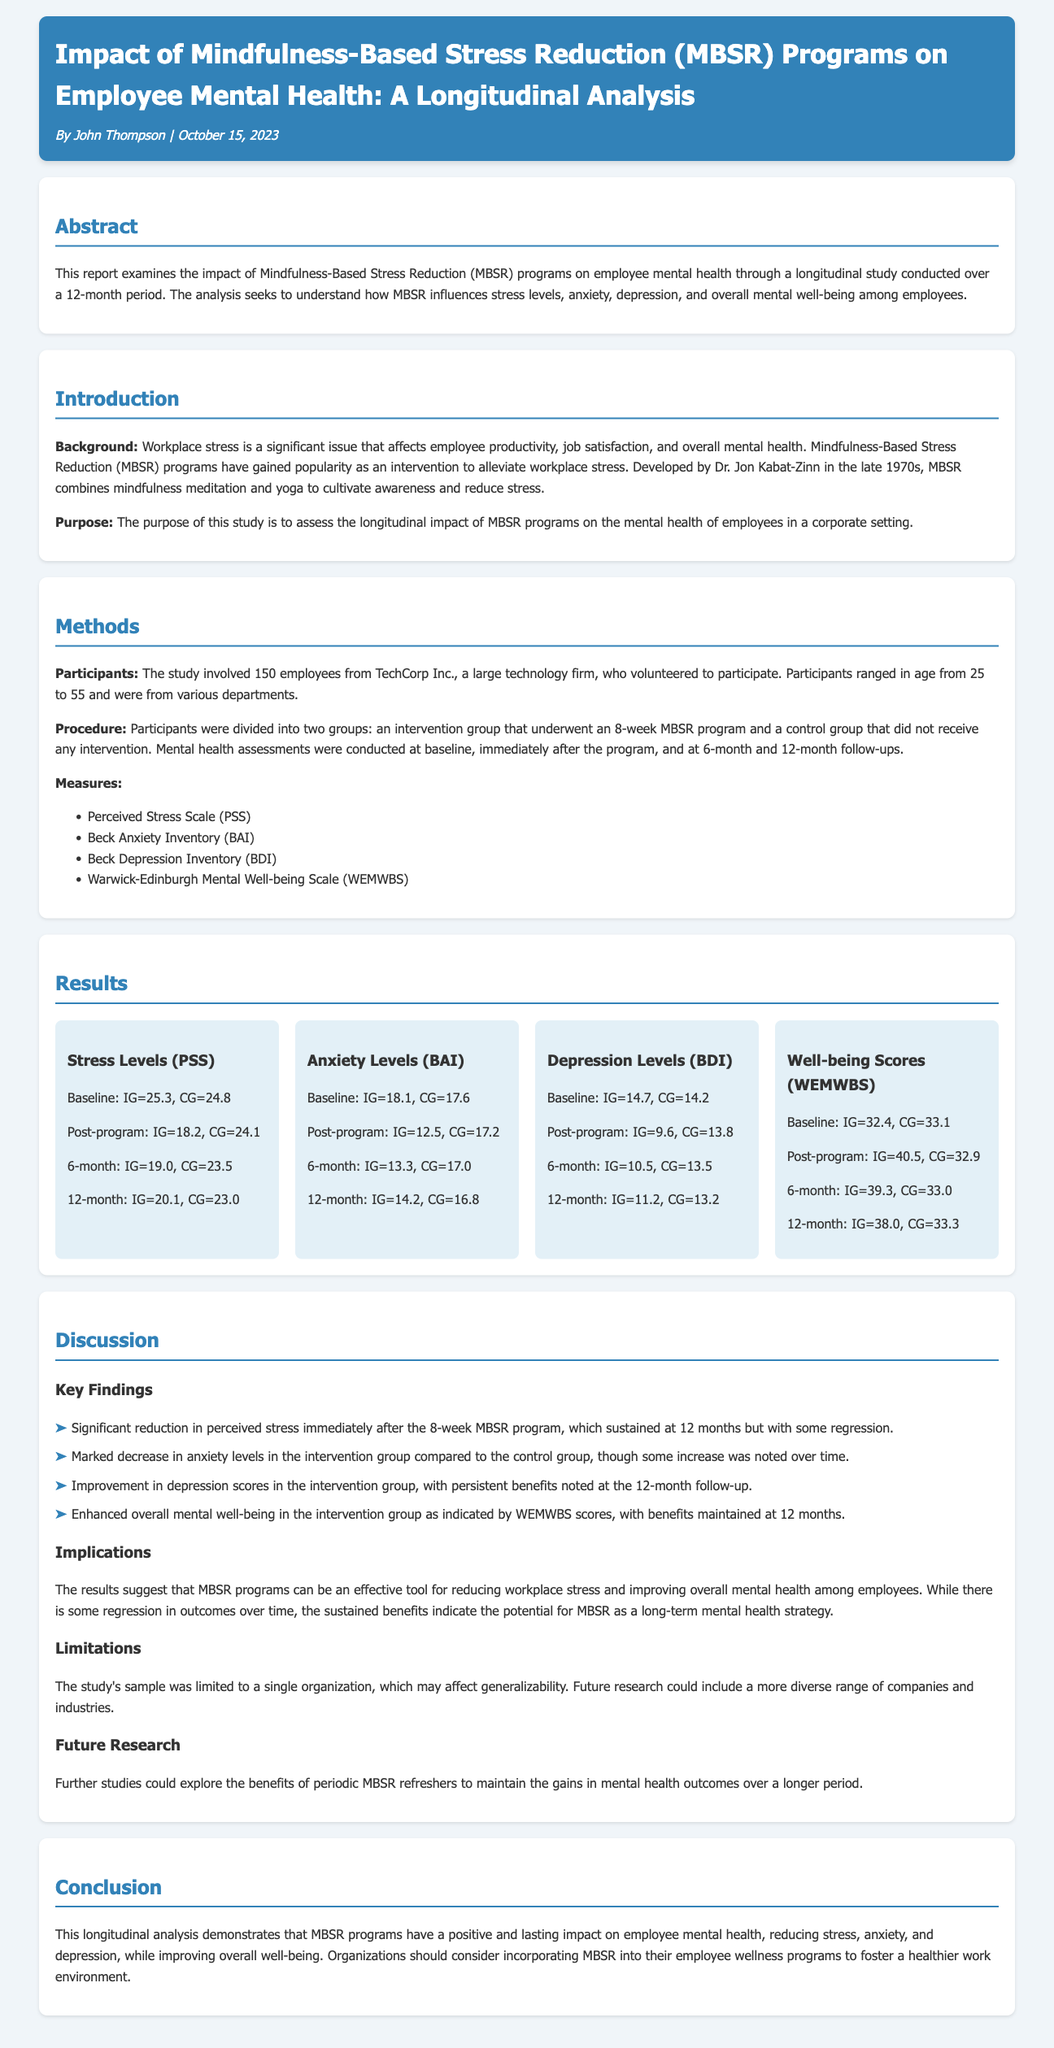What is the sample size of the study? The sample size is explicitly stated in the Methods section of the report, which lists that 150 employees participated in the study.
Answer: 150 What was the duration of the MBSR program? The Methods section specifies that the MBSR program lasted for 8 weeks.
Answer: 8 weeks What scale was used to measure anxiety levels? The Measures section of the report lists the Beck Anxiety Inventory (BAI) as the tool for measuring anxiety levels.
Answer: Beck Anxiety Inventory (BAI) What were the perceived stress levels at baseline for the intervention group? The Results section provides baseline data for the intervention group (IG), indicating that it was 25.3 on the Perceived Stress Scale (PSS).
Answer: 25.3 How did the well-being scores change immediately post-program for the intervention group? According to the Results section, the well-being scores for the intervention group (IG) increased to 40.5 immediately after the program.
Answer: 40.5 What is the primary purpose of the study? The Purpose section of the Introduction outlines that the study's aim is to assess the longitudinal impact of MBSR programs on employee mental health.
Answer: Assess the longitudinal impact of MBSR programs on employee mental health What were the anxiety levels for the control group at 12 months? The Results section indicates that the anxiety levels for the control group (CG) were 16.8 at the 12-month follow-up.
Answer: 16.8 What theme was discussed under 'Implications'? The Discussion section reflects on the implications of the study results, focusing on the effectiveness of MBSR programs to reduce workplace stress.
Answer: Effectiveness of MBSR programs to reduce workplace stress What type of research does the report suggest for the future? The Future Research section calls for further studies exploring the benefits of periodic MBSR refreshers.
Answer: Periodic MBSR refreshers 